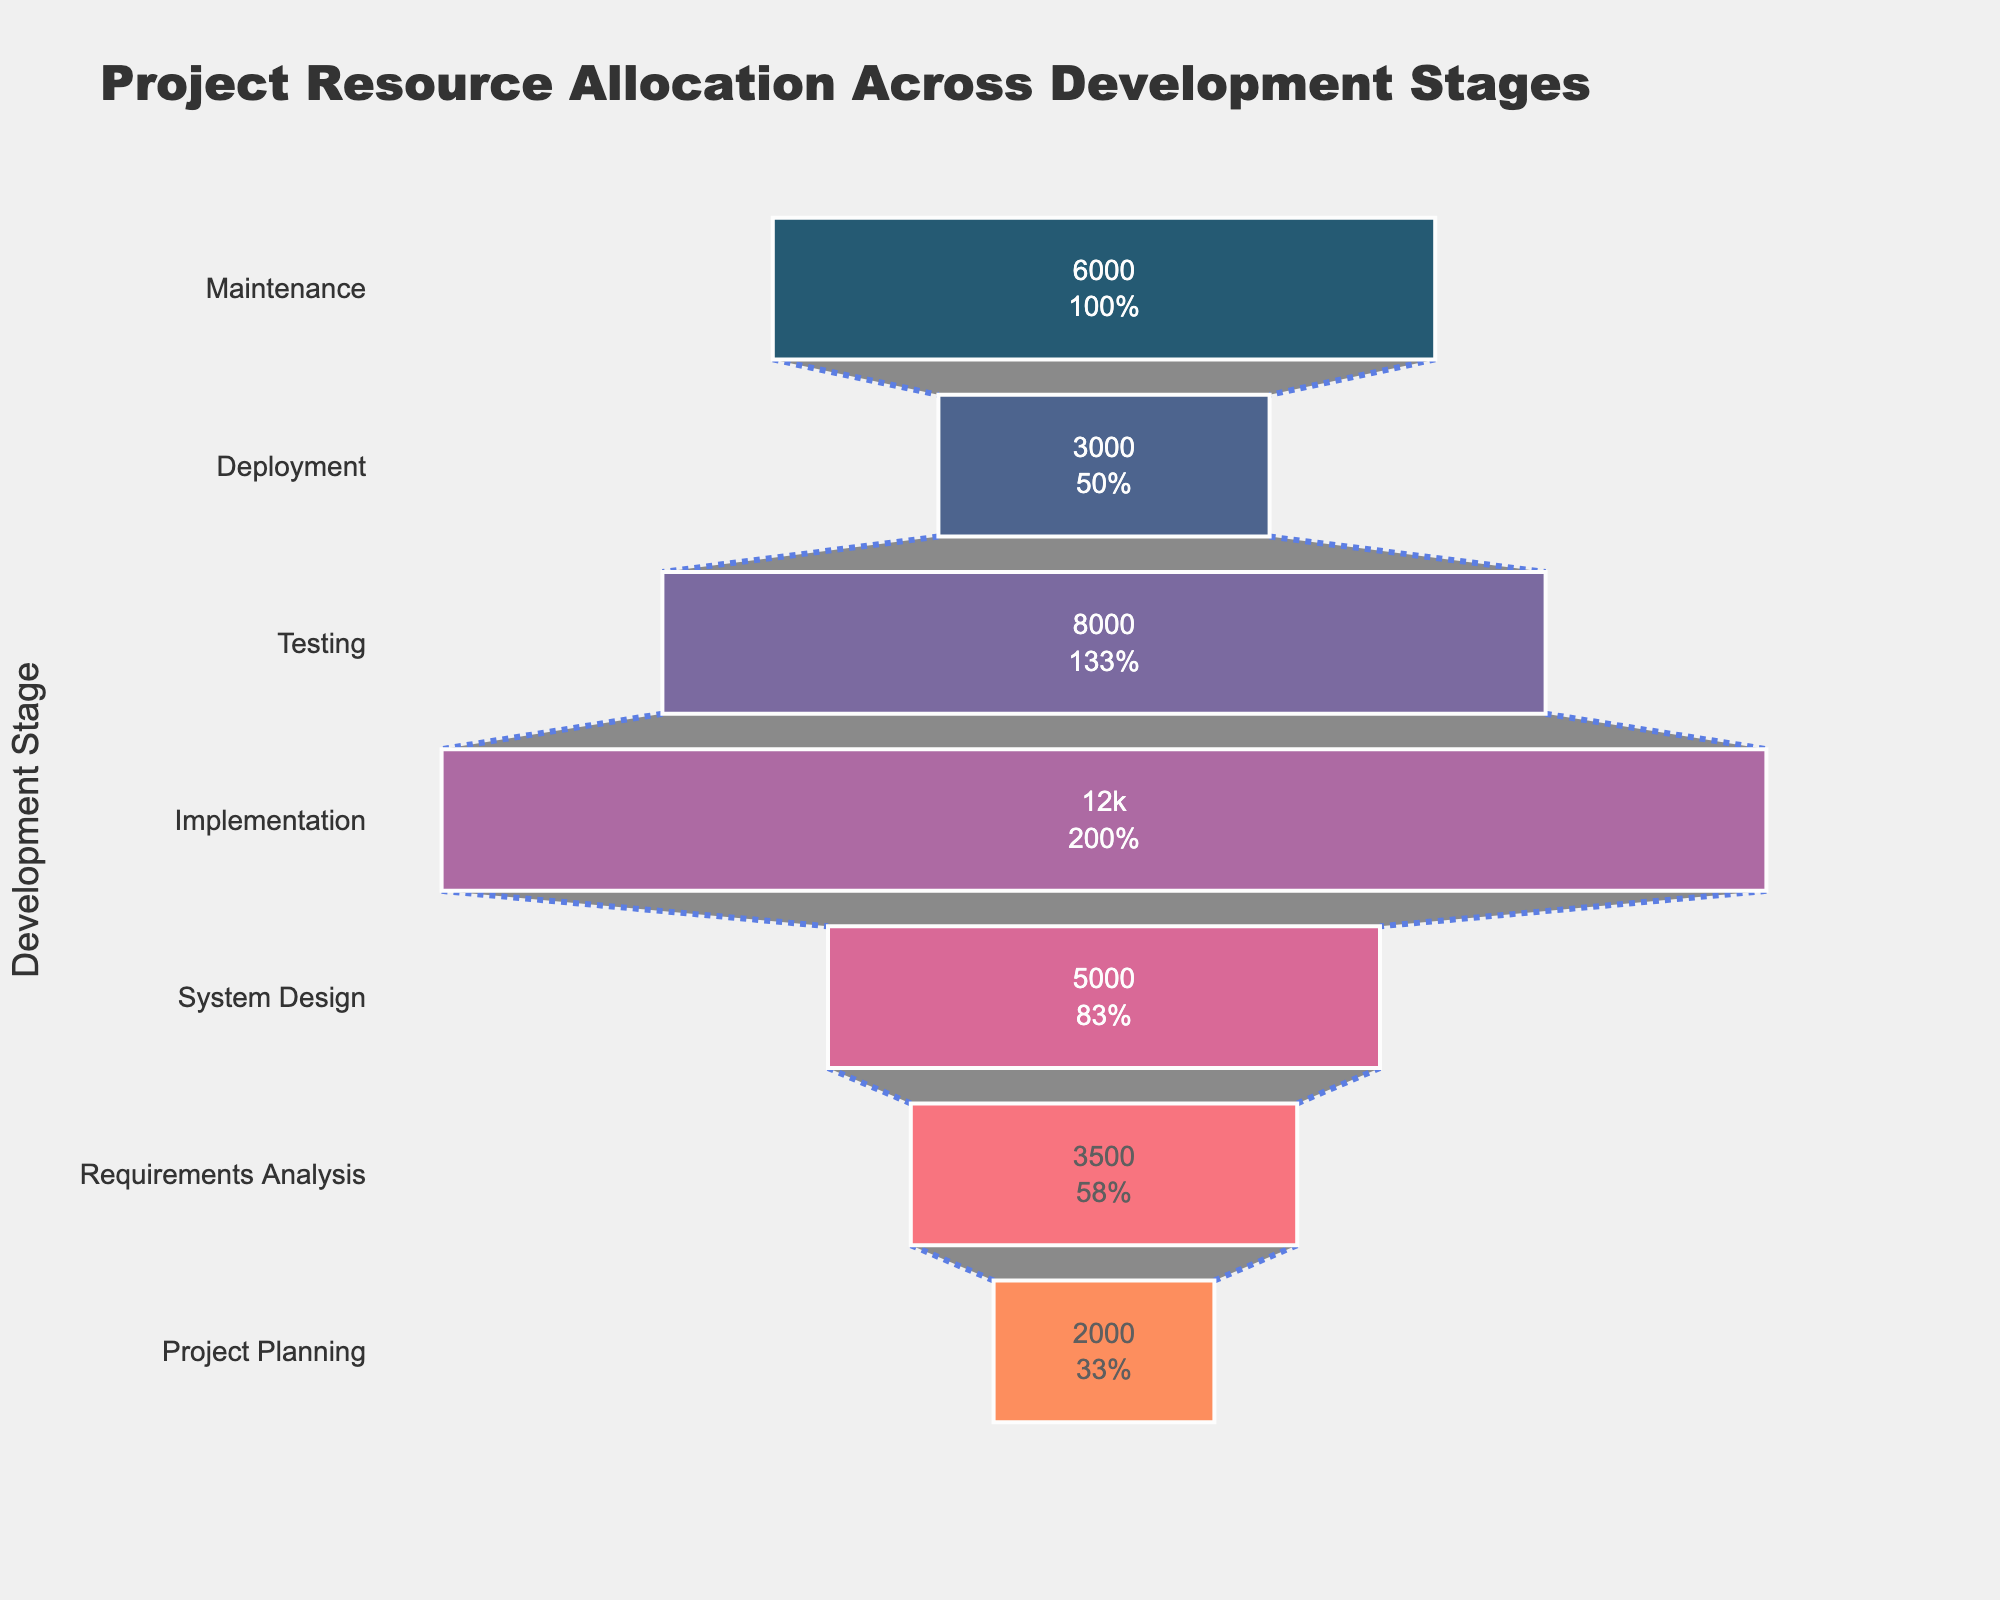What's the title of the figure? The title of the figure is centrally placed at the top and is labeled as "Project Resource Allocation Across Development Stages".
Answer: Project Resource Allocation Across Development Stages What are the stages of the development process shown in the funnel chart? The stages of the development process are listed alongside the y-axis in the following order: Maintenance, Deployment, Testing, Implementation, System Design, Requirements Analysis, Project Planning.
Answer: Maintenance, Deployment, Testing, Implementation, System Design, Requirements Analysis, Project Planning Which stage has the highest resource allocation in person-hours? The stage with the highest resource allocation in person-hours is easily identifiable by the widest section of the funnel located centrally; this is the Implementation stage.
Answer: Implementation How many person-hours are allocated during the Testing stage? The number of person-hours allocated to Testing is displayed inside the corresponding section of the funnel chart; it is 8,000 person-hours.
Answer: 8,000 What is the percentage of resource allocation during the System Design stage relative to the initial planning stage? The percentage of resource allocation for the System Design stage relative to the initial amount allocated in the Project Planning stage can be found within the section for System Design in the funnel chart; it shows the percentage allocation alongside the person-hours.
Answer: 250% What is the difference in resource allocation between the Requirements Analysis stage and the Deployment stage? To find the difference, subtract the person-hours for Deployment (3,000) from the person-hours for Requirements Analysis (3,500); it shows a difference of 500 person-hours.
Answer: 500 Which stage indicates a decrease in resource allocation compared to the Implementation stage? Comparing each stage's resource allocation with that of the Implementation stage (12,000 person-hours), it can be seen that Testing, Deployment, and Maintenance stages all have fewer person-hours allocated.
Answer: Testing, Deployment, Maintenance What stage marks the end of the highest cumulative resource allocation? The highest cumulative allocation is at the widest part of the chart, indicating that Implementation holds the most resources; thus, Implementation is the stage marking this peak.
Answer: Implementation What's the total person-hours allocated from Project Planning to Deployment? To find the total, add the person-hours from Project Planning (2,000) to Deployment (3,000). The sum is 2,000 + 3,500 + 5,000 + 12,000 + 8,000 + 3,000 = 33,500.
Answer: 33,500 How does resource allocation during Maintenance compare to that during Testing? Comparing the Maintenance stage's 6,000 person-hours to the Testing stage's 8,000 person-hours, Maintenance has fewer person-hours allocated.
Answer: Maintenance < Testing 